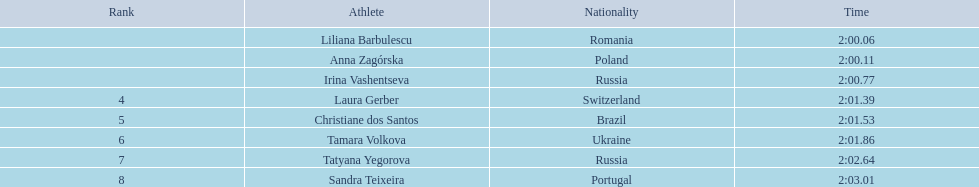Who are all the competitors? Liliana Barbulescu, Anna Zagórska, Irina Vashentseva, Laura Gerber, Christiane dos Santos, Tamara Volkova, Tatyana Yegorova, Sandra Teixeira. What were their timings in the heat? 2:00.06, 2:00.11, 2:00.77, 2:01.39, 2:01.53, 2:01.86, 2:02.64, 2:03.01. Of these, which is the best timing? 2:00.06. Which competitor had this timing? Liliana Barbulescu. 